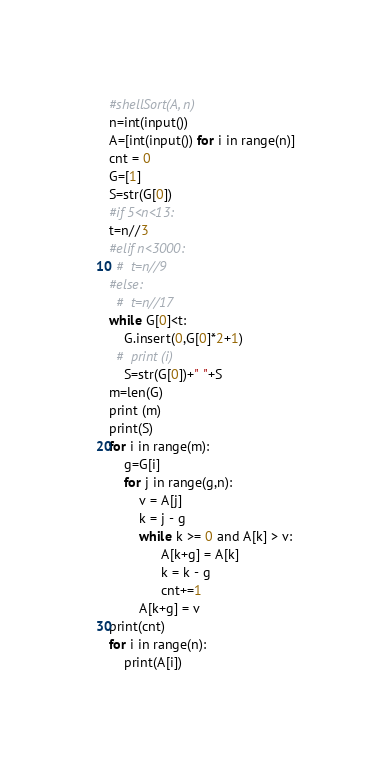<code> <loc_0><loc_0><loc_500><loc_500><_Python_>#shellSort(A, n)
n=int(input())
A=[int(input()) for i in range(n)]
cnt = 0
G=[1]
S=str(G[0])
#if 5<n<13:
t=n//3
#elif n<3000:
  #  t=n//9
#else:
  #  t=n//17
while G[0]<t:
    G.insert(0,G[0]*2+1)
  #  print (i)
    S=str(G[0])+" "+S
m=len(G)
print (m)
print(S)
for i in range(m):
    g=G[i]
    for j in range(g,n):
        v = A[j]
        k = j - g
        while k >= 0 and A[k] > v:
              A[k+g] = A[k]
              k = k - g
              cnt+=1
        A[k+g] = v 
print(cnt)
for i in range(n):
    print(A[i])</code> 